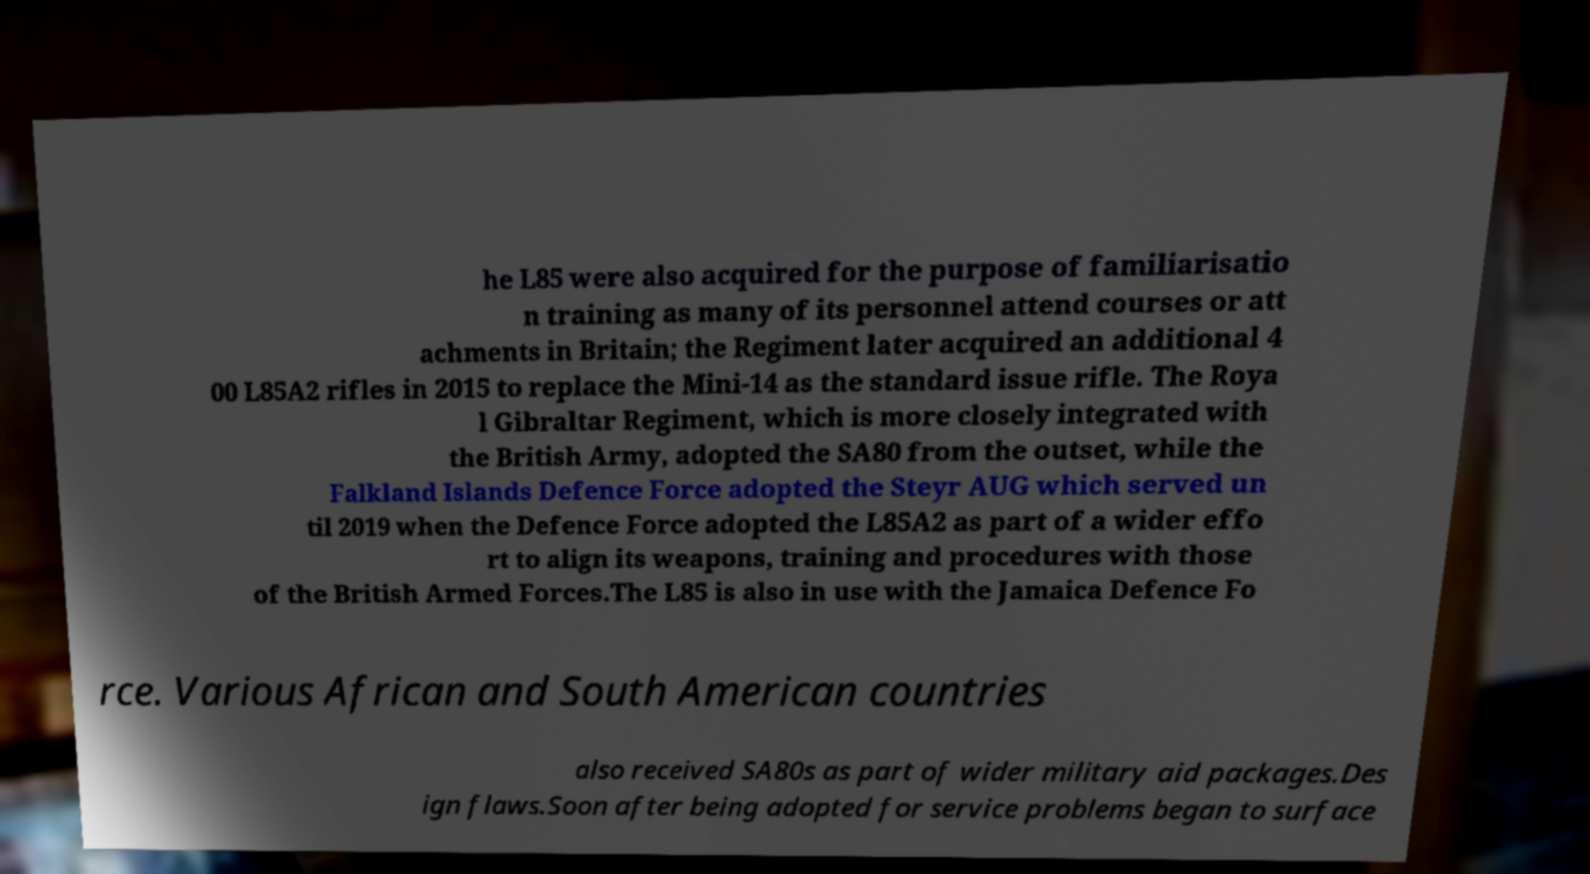For documentation purposes, I need the text within this image transcribed. Could you provide that? he L85 were also acquired for the purpose of familiarisatio n training as many of its personnel attend courses or att achments in Britain; the Regiment later acquired an additional 4 00 L85A2 rifles in 2015 to replace the Mini-14 as the standard issue rifle. The Roya l Gibraltar Regiment, which is more closely integrated with the British Army, adopted the SA80 from the outset, while the Falkland Islands Defence Force adopted the Steyr AUG which served un til 2019 when the Defence Force adopted the L85A2 as part of a wider effo rt to align its weapons, training and procedures with those of the British Armed Forces.The L85 is also in use with the Jamaica Defence Fo rce. Various African and South American countries also received SA80s as part of wider military aid packages.Des ign flaws.Soon after being adopted for service problems began to surface 